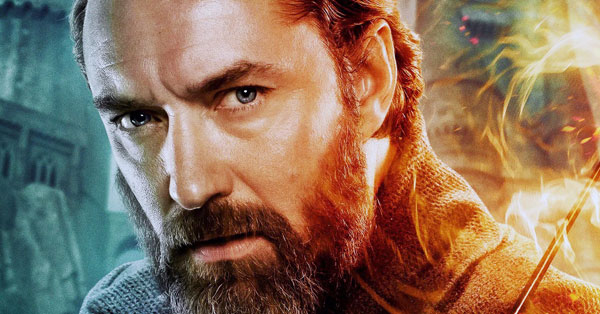Imagine Arion faces a mythical creature. How does he handle the encounter? When Arion faces a mythical creature, such as a fearsome dragon that has emerged from the depths of the Eldor Mountains, he approaches the encounter with a blend of caution and confidence. Summoning his magical staff, he projects a powerful barrier to protect himself and any nearby innocents. Arion then uses his knowledge of ancient dragon lore to communicate with the creature, seeking to understand its motives. He combines spells of persuasion and calm to de-escalate the situation, ensuring that combat is a last resort. If forced into battle, Arion's mastery of elemental magic would allow him to counter the dragon's fiery breath with torrents of water and frigid ice, gradually wearing it down without causing unnecessary harm. What might Arion's battle cry be in such a moment? Arion raises his staff high, a brilliant light emanating from its core, and with a voice that echoes through the mountains, he shouts, 'By the ancient powers of Eldrake, I command thee to stand down!' 